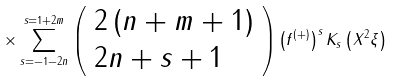Convert formula to latex. <formula><loc_0><loc_0><loc_500><loc_500>\times \sum _ { s = - 1 - 2 n } ^ { s = 1 + 2 m } \left ( \begin{array} { l } 2 \left ( n + m + 1 \right ) \\ 2 n + s + 1 \end{array} \right ) \left ( f ^ { \left ( + \right ) } \right ) ^ { s } K _ { s } \left ( X ^ { 2 } \xi \right )</formula> 